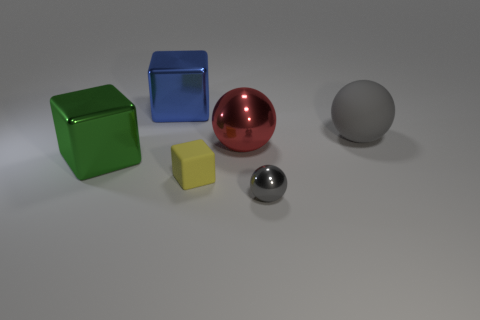What number of things are large brown metallic cylinders or big green cubes?
Your response must be concise. 1. Is there any other thing that has the same color as the big rubber object?
Make the answer very short. Yes. Is the material of the green thing the same as the gray sphere that is behind the large metallic ball?
Offer a terse response. No. What is the shape of the blue shiny object behind the gray object right of the gray shiny ball?
Offer a very short reply. Cube. The large object that is both right of the large blue block and in front of the big gray thing has what shape?
Provide a short and direct response. Sphere. How many objects are either small gray metal balls or cubes that are in front of the big shiny sphere?
Offer a very short reply. 3. There is another gray object that is the same shape as the small gray thing; what is its material?
Your response must be concise. Rubber. What is the big object that is behind the red metallic sphere and on the left side of the small yellow rubber block made of?
Give a very brief answer. Metal. How many other objects have the same shape as the yellow thing?
Provide a succinct answer. 2. There is a shiny cube behind the shiny ball left of the small ball; what color is it?
Provide a short and direct response. Blue. 